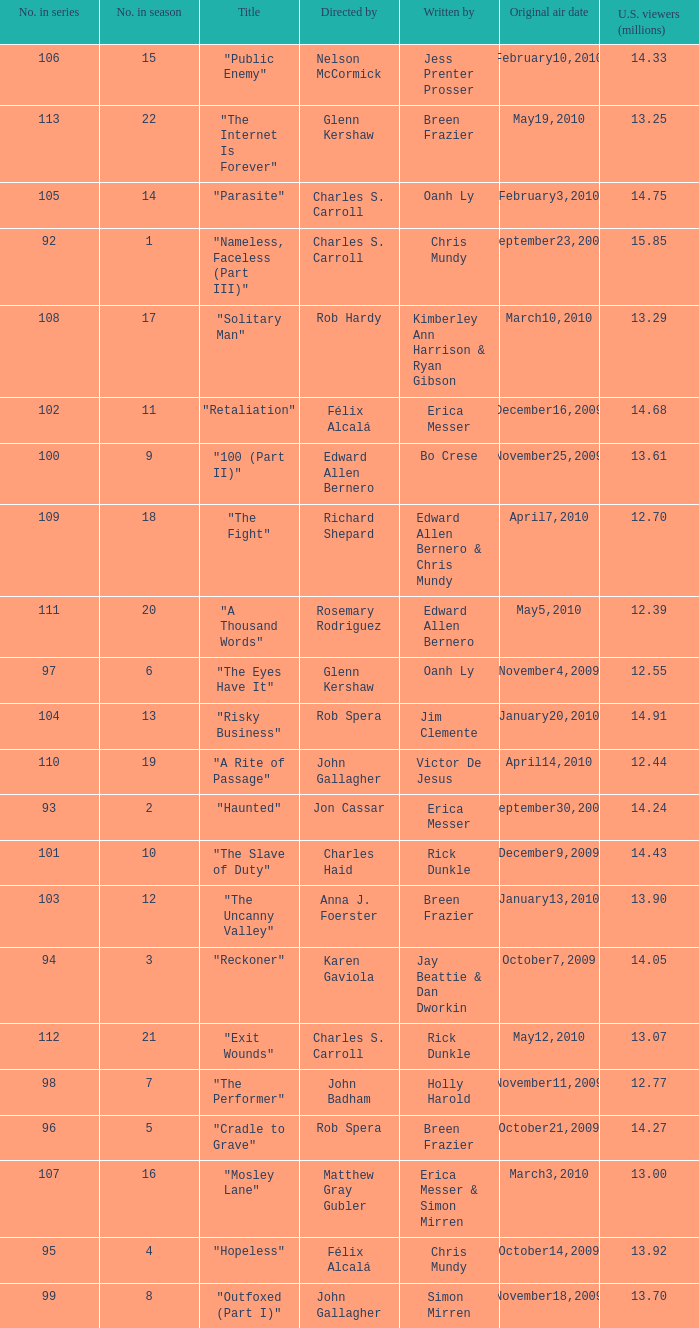What season was the episode "haunted" in? 2.0. 